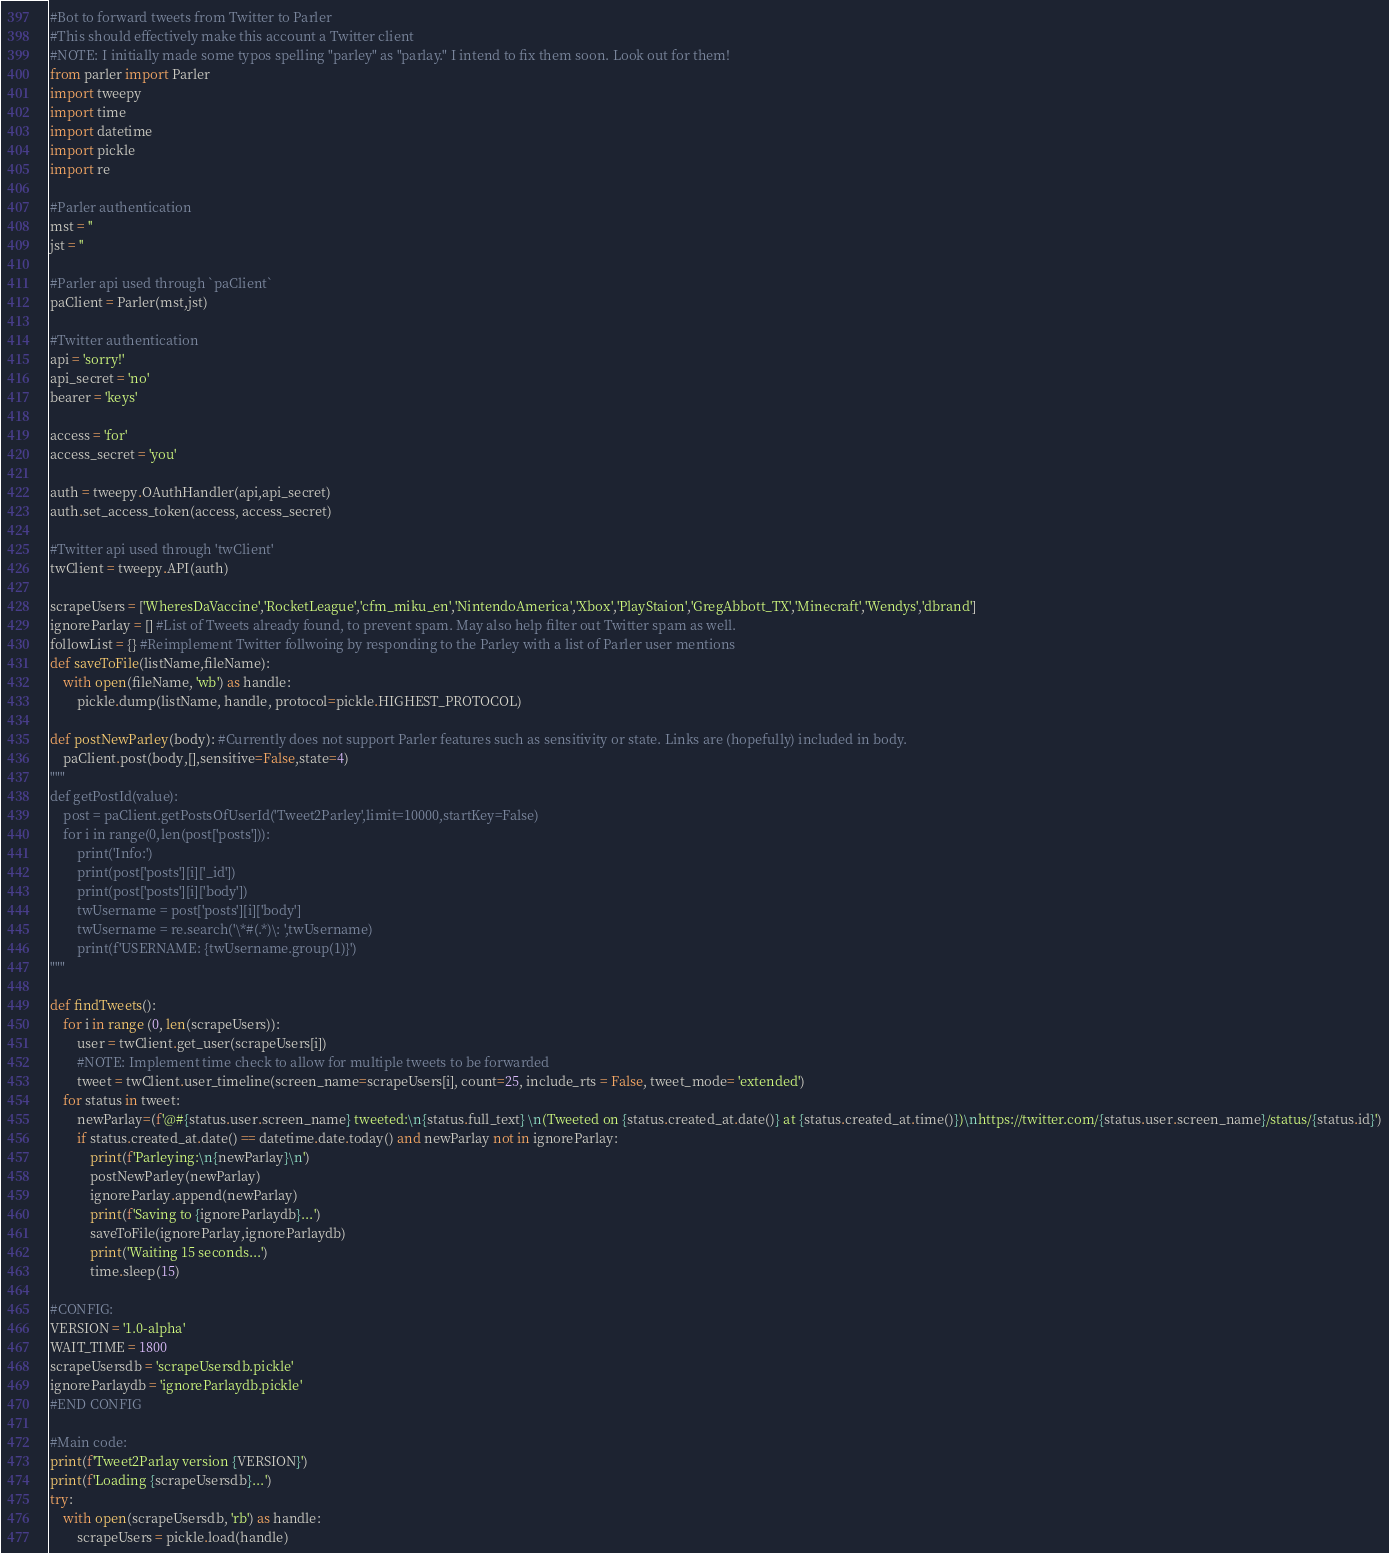Convert code to text. <code><loc_0><loc_0><loc_500><loc_500><_Python_>#Bot to forward tweets from Twitter to Parler
#This should effectively make this account a Twitter client
#NOTE: I initially made some typos spelling "parley" as "parlay." I intend to fix them soon. Look out for them!
from parler import Parler
import tweepy
import time
import datetime
import pickle
import re

#Parler authentication
mst = ''
jst = ''

#Parler api used through `paClient`
paClient = Parler(mst,jst)

#Twitter authentication
api = 'sorry!'
api_secret = 'no'
bearer = 'keys'

access = 'for'
access_secret = 'you'

auth = tweepy.OAuthHandler(api,api_secret)
auth.set_access_token(access, access_secret)

#Twitter api used through 'twClient'
twClient = tweepy.API(auth)

scrapeUsers = ['WheresDaVaccine','RocketLeague','cfm_miku_en','NintendoAmerica','Xbox','PlayStaion','GregAbbott_TX','Minecraft','Wendys','dbrand']
ignoreParlay = [] #List of Tweets already found, to prevent spam. May also help filter out Twitter spam as well.
followList = {} #Reimplement Twitter follwoing by responding to the Parley with a list of Parler user mentions
def saveToFile(listName,fileName):
    with open(fileName, 'wb') as handle:
        pickle.dump(listName, handle, protocol=pickle.HIGHEST_PROTOCOL)

def postNewParley(body): #Currently does not support Parler features such as sensitivity or state. Links are (hopefully) included in body.
    paClient.post(body,[],sensitive=False,state=4)
"""
def getPostId(value):
    post = paClient.getPostsOfUserId('Tweet2Parley',limit=10000,startKey=False)
    for i in range(0,len(post['posts'])):
        print('Info:')
        print(post['posts'][i]['_id'])
        print(post['posts'][i]['body'])
        twUsername = post['posts'][i]['body']
        twUsername = re.search('\*#(.*)\: ',twUsername)
        print(f'USERNAME: {twUsername.group(1)}')
"""

def findTweets():
    for i in range (0, len(scrapeUsers)):
        user = twClient.get_user(scrapeUsers[i])
        #NOTE: Implement time check to allow for multiple tweets to be forwarded
        tweet = twClient.user_timeline(screen_name=scrapeUsers[i], count=25, include_rts = False, tweet_mode= 'extended')
    for status in tweet:
        newParlay=(f'@#{status.user.screen_name} tweeted:\n{status.full_text} \n(Tweeted on {status.created_at.date()} at {status.created_at.time()})\nhttps://twitter.com/{status.user.screen_name}/status/{status.id}')
        if status.created_at.date() == datetime.date.today() and newParlay not in ignoreParlay:
            print(f'Parleying:\n{newParlay}\n')
            postNewParley(newParlay)
            ignoreParlay.append(newParlay)
            print(f'Saving to {ignoreParlaydb}...')
            saveToFile(ignoreParlay,ignoreParlaydb)
            print('Waiting 15 seconds...')
            time.sleep(15)

#CONFIG:
VERSION = '1.0-alpha'
WAIT_TIME = 1800
scrapeUsersdb = 'scrapeUsersdb.pickle'
ignoreParlaydb = 'ignoreParlaydb.pickle'
#END CONFIG

#Main code:
print(f'Tweet2Parlay version {VERSION}')
print(f'Loading {scrapeUsersdb}...')
try:
    with open(scrapeUsersdb, 'rb') as handle:
        scrapeUsers = pickle.load(handle)</code> 